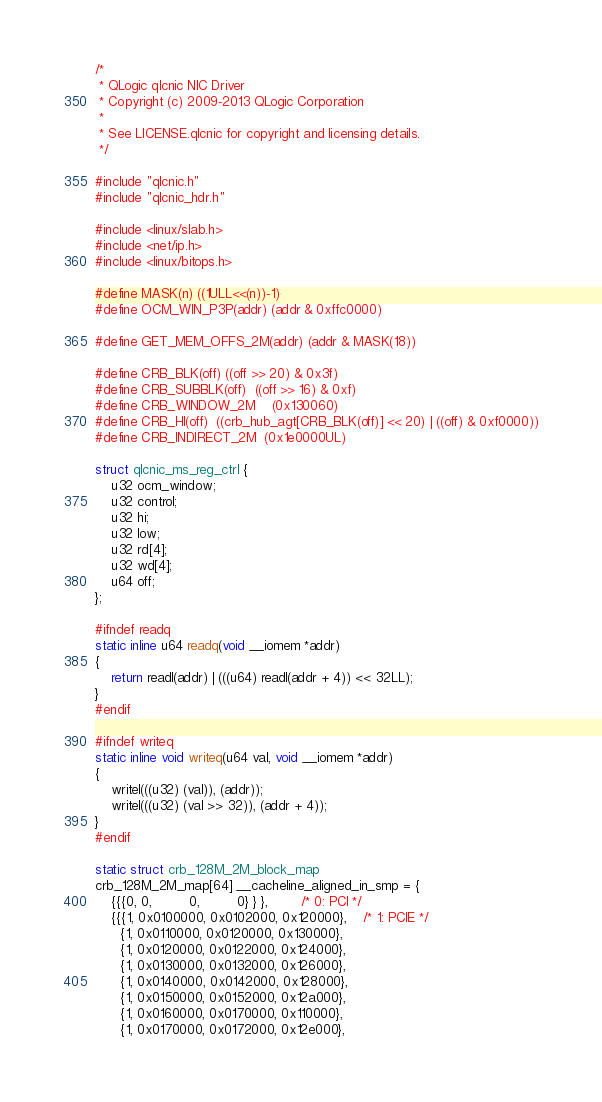Convert code to text. <code><loc_0><loc_0><loc_500><loc_500><_C_>/*
 * QLogic qlcnic NIC Driver
 * Copyright (c) 2009-2013 QLogic Corporation
 *
 * See LICENSE.qlcnic for copyright and licensing details.
 */

#include "qlcnic.h"
#include "qlcnic_hdr.h"

#include <linux/slab.h>
#include <net/ip.h>
#include <linux/bitops.h>

#define MASK(n) ((1ULL<<(n))-1)
#define OCM_WIN_P3P(addr) (addr & 0xffc0000)

#define GET_MEM_OFFS_2M(addr) (addr & MASK(18))

#define CRB_BLK(off)	((off >> 20) & 0x3f)
#define CRB_SUBBLK(off)	((off >> 16) & 0xf)
#define CRB_WINDOW_2M	(0x130060)
#define CRB_HI(off)	((crb_hub_agt[CRB_BLK(off)] << 20) | ((off) & 0xf0000))
#define CRB_INDIRECT_2M	(0x1e0000UL)

struct qlcnic_ms_reg_ctrl {
	u32 ocm_window;
	u32 control;
	u32 hi;
	u32 low;
	u32 rd[4];
	u32 wd[4];
	u64 off;
};

#ifndef readq
static inline u64 readq(void __iomem *addr)
{
	return readl(addr) | (((u64) readl(addr + 4)) << 32LL);
}
#endif

#ifndef writeq
static inline void writeq(u64 val, void __iomem *addr)
{
	writel(((u32) (val)), (addr));
	writel(((u32) (val >> 32)), (addr + 4));
}
#endif

static struct crb_128M_2M_block_map
crb_128M_2M_map[64] __cacheline_aligned_in_smp = {
    {{{0, 0,         0,         0} } },		/* 0: PCI */
    {{{1, 0x0100000, 0x0102000, 0x120000},	/* 1: PCIE */
	  {1, 0x0110000, 0x0120000, 0x130000},
	  {1, 0x0120000, 0x0122000, 0x124000},
	  {1, 0x0130000, 0x0132000, 0x126000},
	  {1, 0x0140000, 0x0142000, 0x128000},
	  {1, 0x0150000, 0x0152000, 0x12a000},
	  {1, 0x0160000, 0x0170000, 0x110000},
	  {1, 0x0170000, 0x0172000, 0x12e000},</code> 